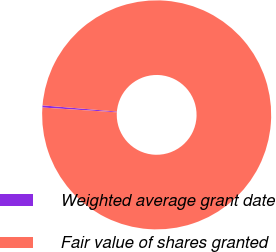Convert chart. <chart><loc_0><loc_0><loc_500><loc_500><pie_chart><fcel>Weighted average grant date<fcel>Fair value of shares granted<nl><fcel>0.3%<fcel>99.7%<nl></chart> 